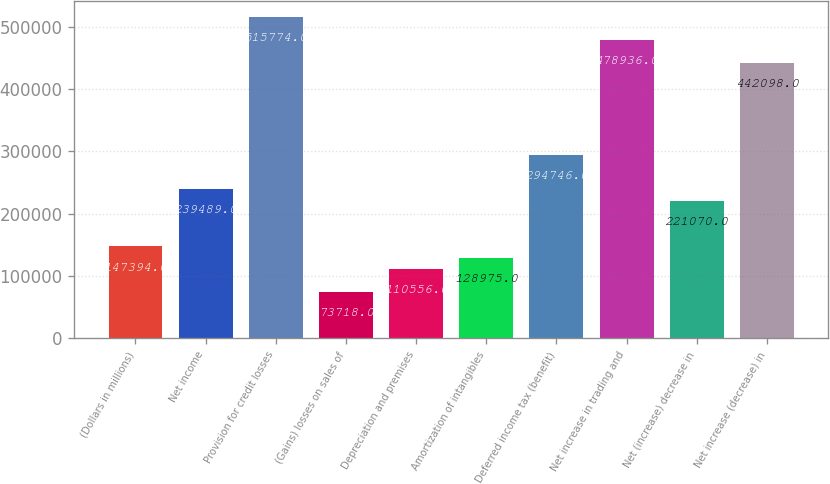Convert chart to OTSL. <chart><loc_0><loc_0><loc_500><loc_500><bar_chart><fcel>(Dollars in millions)<fcel>Net income<fcel>Provision for credit losses<fcel>(Gains) losses on sales of<fcel>Depreciation and premises<fcel>Amortization of intangibles<fcel>Deferred income tax (benefit)<fcel>Net increase in trading and<fcel>Net (increase) decrease in<fcel>Net increase (decrease) in<nl><fcel>147394<fcel>239489<fcel>515774<fcel>73718<fcel>110556<fcel>128975<fcel>294746<fcel>478936<fcel>221070<fcel>442098<nl></chart> 